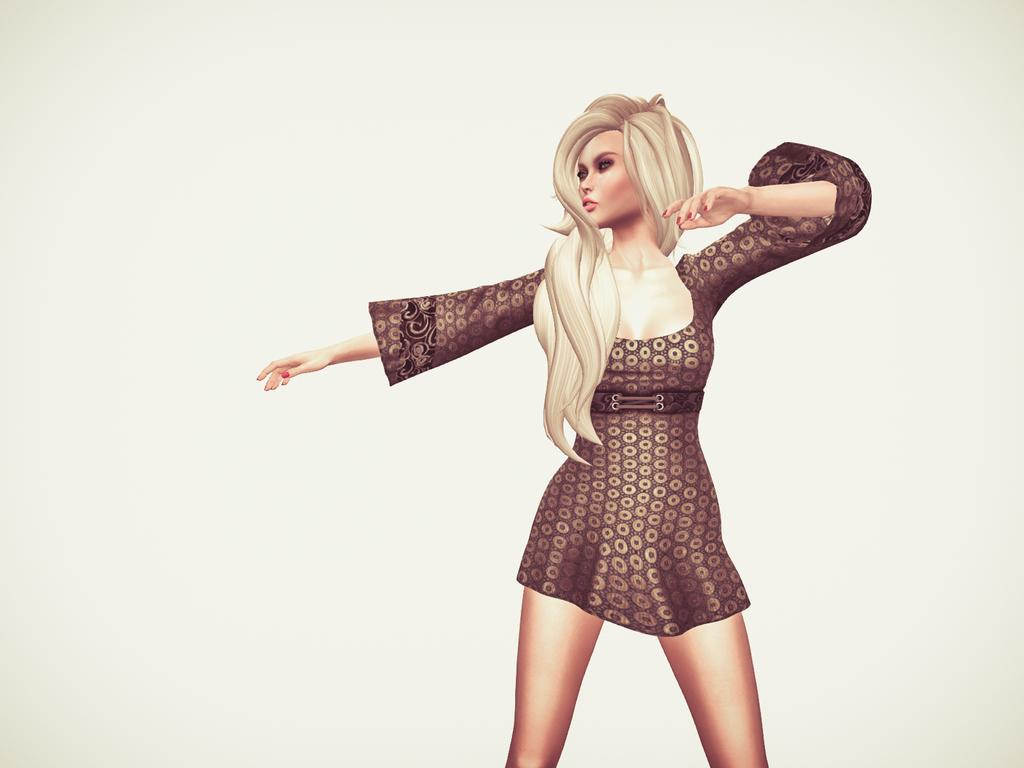Who is the main subject in the picture? There is a woman in the picture. What is the woman doing in the image? The woman is standing. What is the woman wearing in the image? The woman is wearing a dress. In which direction is the woman looking? The woman is looking at the left side. What is the background of the image? There is a white backdrop in the image. What type of reward is the woman receiving in the image? There is no indication in the image that the woman is receiving a reward, so it cannot be determined from the picture. 